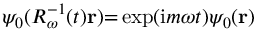<formula> <loc_0><loc_0><loc_500><loc_500>\psi _ { 0 } ( { R _ { \omega } } ^ { - 1 } ( t ) r ) { = } \exp ( i m \omega t ) \psi _ { 0 } ( r )</formula> 